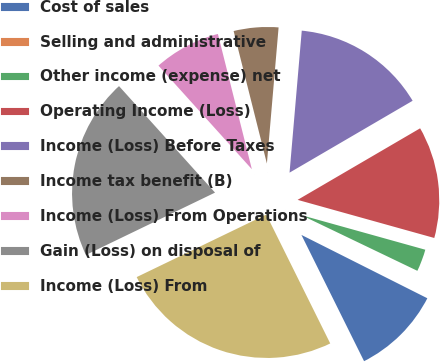Convert chart. <chart><loc_0><loc_0><loc_500><loc_500><pie_chart><fcel>Cost of sales<fcel>Selling and administrative<fcel>Other income (expense) net<fcel>Operating Income (Loss)<fcel>Income (Loss) Before Taxes<fcel>Income tax benefit (B)<fcel>Income (Loss) From Operations<fcel>Gain (Loss) on disposal of<fcel>Income (Loss) From<nl><fcel>10.25%<fcel>0.3%<fcel>2.79%<fcel>12.74%<fcel>15.22%<fcel>5.28%<fcel>7.76%<fcel>20.48%<fcel>25.17%<nl></chart> 